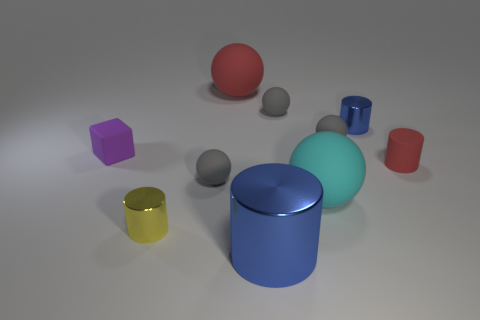How many gray spheres must be subtracted to get 1 gray spheres? 2 Subtract all gray cylinders. How many gray spheres are left? 3 Subtract all red balls. How many balls are left? 4 Subtract all gray spheres. Subtract all red blocks. How many spheres are left? 2 Subtract all cubes. How many objects are left? 9 Add 4 red cylinders. How many red cylinders exist? 5 Subtract 0 green balls. How many objects are left? 10 Subtract all tiny rubber cylinders. Subtract all large blue cylinders. How many objects are left? 8 Add 1 large cyan matte balls. How many large cyan matte balls are left? 2 